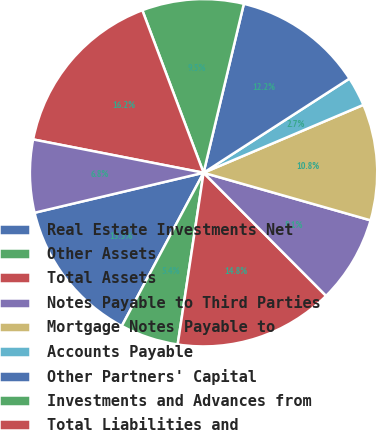<chart> <loc_0><loc_0><loc_500><loc_500><pie_chart><fcel>Real Estate Investments Net<fcel>Other Assets<fcel>Total Assets<fcel>Notes Payable to Third Parties<fcel>Mortgage Notes Payable to<fcel>Accounts Payable<fcel>Other Partners' Capital<fcel>Investments and Advances from<fcel>Total Liabilities and<fcel>Rental and Interest Income<nl><fcel>13.5%<fcel>5.42%<fcel>14.84%<fcel>8.12%<fcel>10.81%<fcel>2.73%<fcel>12.15%<fcel>9.46%<fcel>16.19%<fcel>6.77%<nl></chart> 